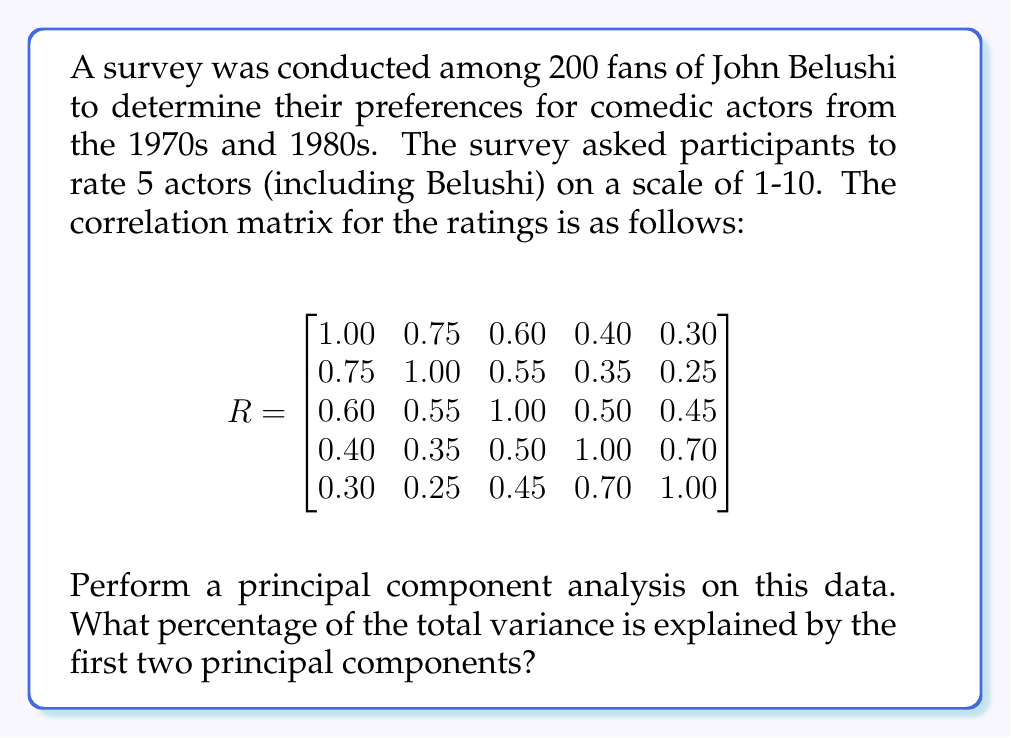Can you solve this math problem? To perform principal component analysis (PCA) on this correlation matrix, we need to follow these steps:

1. Calculate the eigenvalues and eigenvectors of the correlation matrix.
2. Order the eigenvalues from largest to smallest.
3. Calculate the proportion of variance explained by each principal component.
4. Sum the proportion of variance for the first two principal components.

Step 1: Calculate eigenvalues and eigenvectors
Using a mathematical software or calculator, we find the eigenvalues of the correlation matrix R:

$\lambda_1 = 3.0253$
$\lambda_2 = 0.8947$
$\lambda_3 = 0.5232$
$\lambda_4 = 0.3441$
$\lambda_5 = 0.2127$

Step 2: Order eigenvalues
The eigenvalues are already in descending order.

Step 3: Calculate proportion of variance explained
The proportion of variance explained by each principal component is calculated by dividing each eigenvalue by the sum of all eigenvalues:

Total variance = $\sum_{i=1}^5 \lambda_i = 5$

Proportion of variance for PC1 = $\frac{\lambda_1}{5} = \frac{3.0253}{5} = 0.6051$ or 60.51%
Proportion of variance for PC2 = $\frac{\lambda_2}{5} = \frac{0.8947}{5} = 0.1789$ or 17.89%

Step 4: Sum the proportion of variance for the first two PCs
Total proportion of variance explained by PC1 and PC2:
$0.6051 + 0.1789 = 0.7840$ or 78.40%

Therefore, the first two principal components explain 78.40% of the total variance in the survey data.
Answer: The first two principal components explain 78.40% of the total variance in the survey data. 